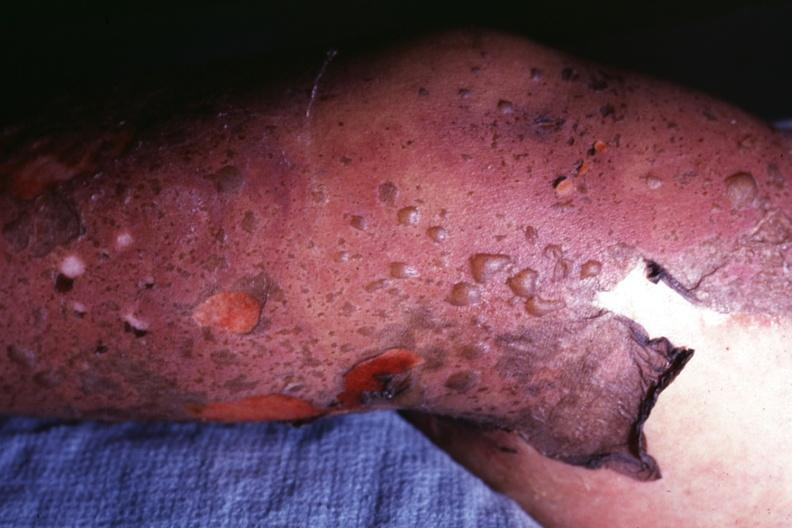does lymphoblastic lymphoma show close-up of bullous skin lesions and peeling of skin?
Answer the question using a single word or phrase. No 